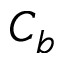<formula> <loc_0><loc_0><loc_500><loc_500>C _ { b }</formula> 